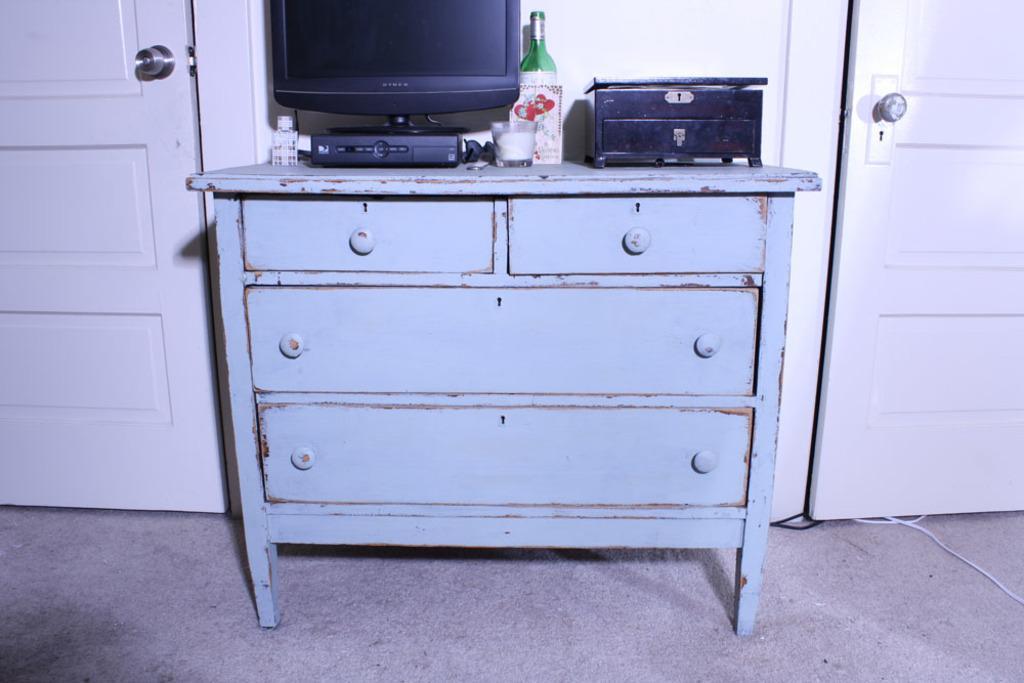In one or two sentences, can you explain what this image depicts? In the picture we can see table with drawers. On the table we can find a television, a setup box, wine bottle and a glass. Two doors are placed on the either side of the table. 